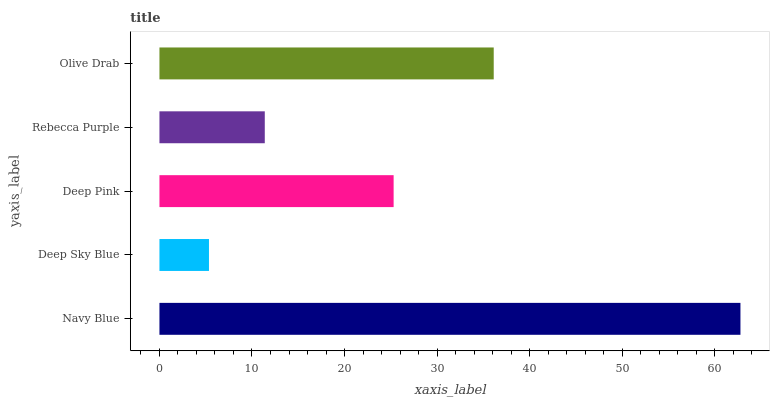Is Deep Sky Blue the minimum?
Answer yes or no. Yes. Is Navy Blue the maximum?
Answer yes or no. Yes. Is Deep Pink the minimum?
Answer yes or no. No. Is Deep Pink the maximum?
Answer yes or no. No. Is Deep Pink greater than Deep Sky Blue?
Answer yes or no. Yes. Is Deep Sky Blue less than Deep Pink?
Answer yes or no. Yes. Is Deep Sky Blue greater than Deep Pink?
Answer yes or no. No. Is Deep Pink less than Deep Sky Blue?
Answer yes or no. No. Is Deep Pink the high median?
Answer yes or no. Yes. Is Deep Pink the low median?
Answer yes or no. Yes. Is Olive Drab the high median?
Answer yes or no. No. Is Olive Drab the low median?
Answer yes or no. No. 